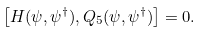<formula> <loc_0><loc_0><loc_500><loc_500>\left [ H ( \psi , \psi ^ { \dagger } ) , Q _ { 5 } ( \psi , \psi ^ { \dagger } ) \right ] = 0 .</formula> 